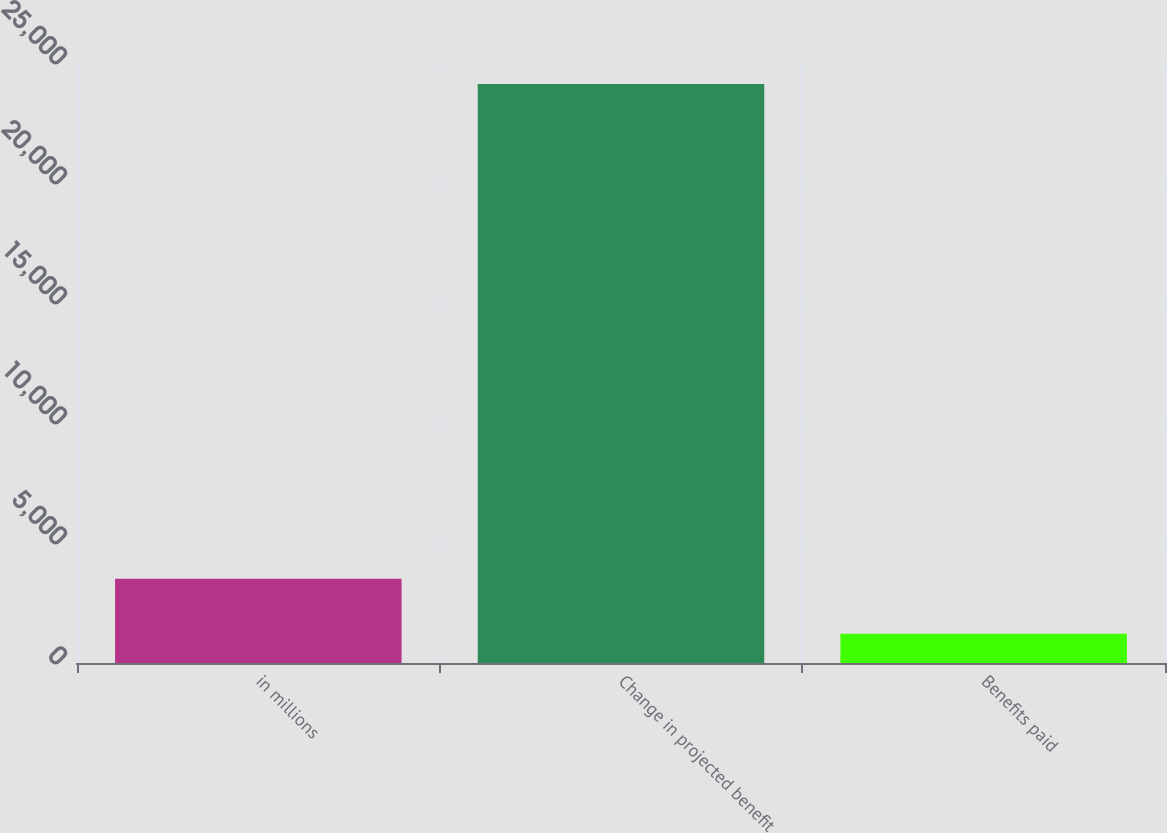Convert chart. <chart><loc_0><loc_0><loc_500><loc_500><bar_chart><fcel>in millions<fcel>Change in projected benefit<fcel>Benefits paid<nl><fcel>3510.9<fcel>24129<fcel>1220<nl></chart> 